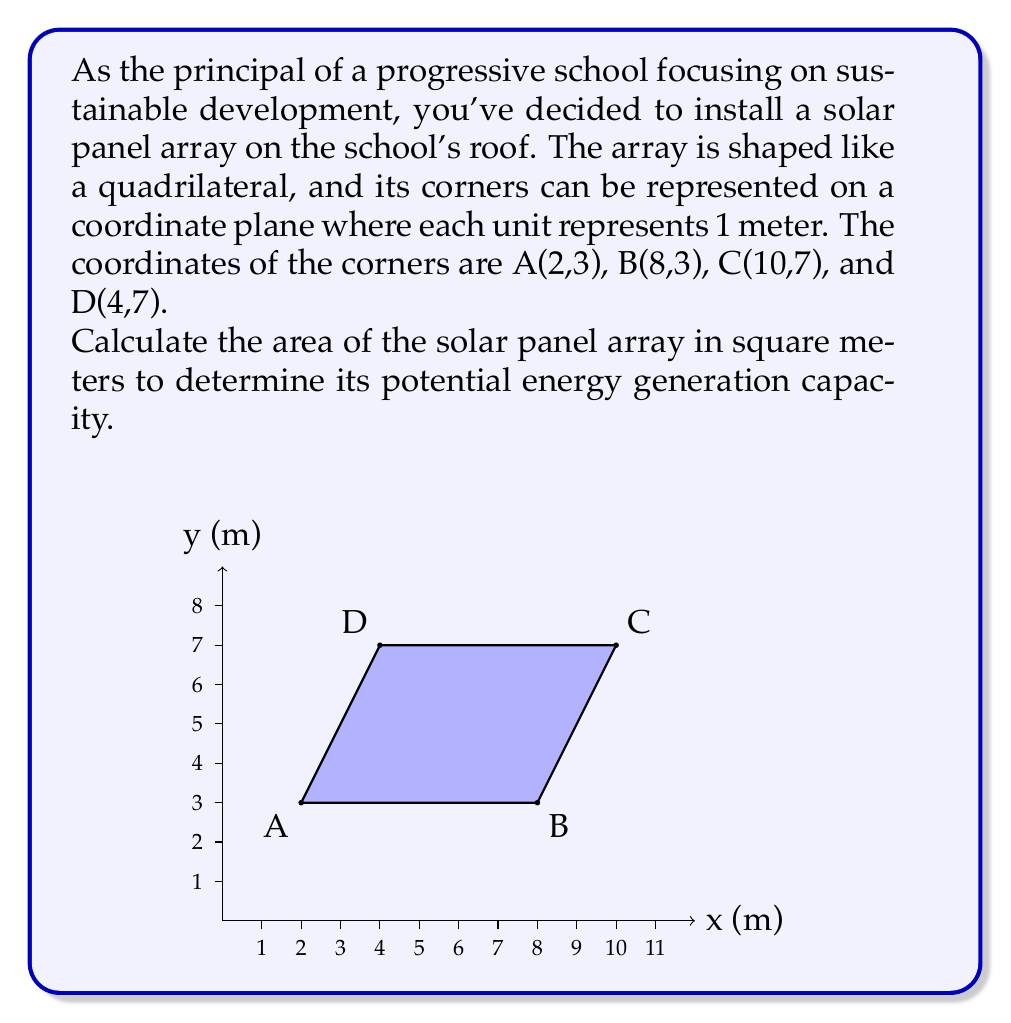Could you help me with this problem? To calculate the area of the quadrilateral solar panel array, we can use the shoelace formula (also known as the surveyor's formula). This method is particularly useful for calculating the area of a polygon given the coordinates of its vertices.

The shoelace formula for a quadrilateral with vertices $(x_1, y_1)$, $(x_2, y_2)$, $(x_3, y_3)$, and $(x_4, y_4)$ is:

$$\text{Area} = \frac{1}{2}|(x_1y_2 + x_2y_3 + x_3y_4 + x_4y_1) - (y_1x_2 + y_2x_3 + y_3x_4 + y_4x_1)|$$

Let's substitute the given coordinates:
A(2,3), B(8,3), C(10,7), D(4,7)

$$\begin{align*}
\text{Area} &= \frac{1}{2}|(2 \cdot 3 + 8 \cdot 7 + 10 \cdot 7 + 4 \cdot 3) - (3 \cdot 8 + 3 \cdot 10 + 7 \cdot 4 + 7 \cdot 2)|\\
&= \frac{1}{2}|(6 + 56 + 70 + 12) - (24 + 30 + 28 + 14)|\\
&= \frac{1}{2}|144 - 96|\\
&= \frac{1}{2} \cdot 48\\
&= 24
\end{align*}$$

Therefore, the area of the solar panel array is 24 square meters.
Answer: 24 m² 